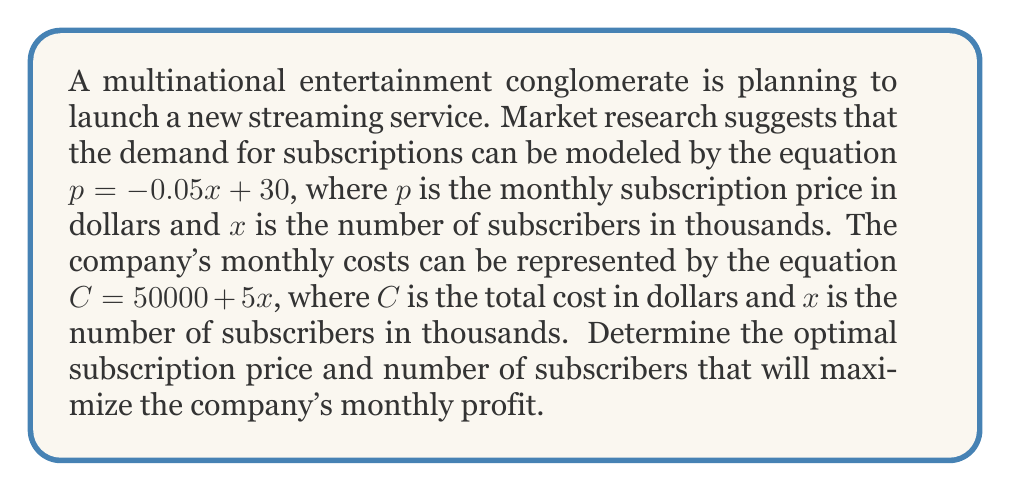Give your solution to this math problem. To solve this problem, we'll follow these steps:

1) First, let's define the profit function. Profit is revenue minus costs:
   $P = R - C$

2) Revenue is price times quantity:
   $R = px = (-0.05x + 30)x = -0.05x^2 + 30x$

3) We're given the cost function:
   $C = 50000 + 5x$

4) Now we can write the profit function:
   $P = R - C = (-0.05x^2 + 30x) - (50000 + 5x)$
   $P = -0.05x^2 + 25x - 50000$

5) To find the maximum profit, we need to find the vertex of this quadratic function. We can do this by finding where the derivative equals zero:
   $\frac{dP}{dx} = -0.1x + 25$
   
   Set this equal to zero:
   $-0.1x + 25 = 0$
   $-0.1x = -25$
   $x = 250$

6) This gives us the optimal number of subscribers (in thousands). To find the optimal price, we plug this back into our original price equation:
   $p = -0.05(250) + 30 = 17.50$

7) We can verify this is a maximum (not a minimum) by checking the second derivative:
   $\frac{d^2P}{dx^2} = -0.1$, which is negative, confirming a maximum.

8) Finally, we can calculate the maximum profit:
   $P = -0.05(250)^2 + 25(250) - 50000 = $3,125,000$
Answer: The optimal subscription price is $17.50 per month, and the optimal number of subscribers is 250,000. This will result in a maximum monthly profit of $3,125,000. 